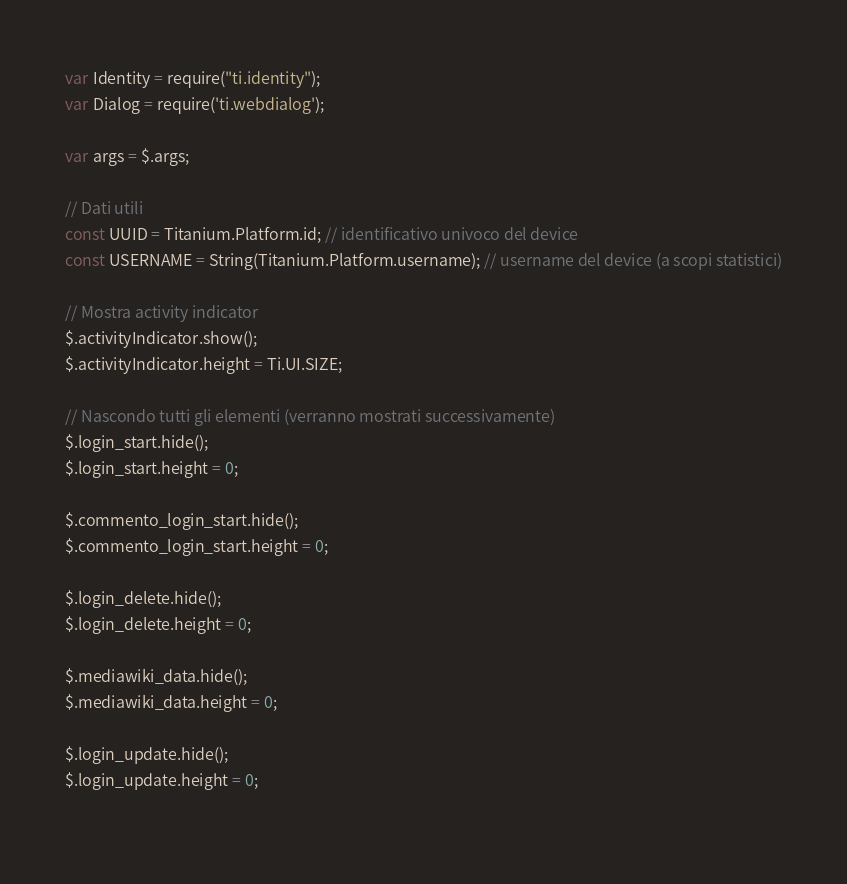Convert code to text. <code><loc_0><loc_0><loc_500><loc_500><_JavaScript_>var Identity = require("ti.identity");
var Dialog = require('ti.webdialog');

var args = $.args;

// Dati utili
const UUID = Titanium.Platform.id; // identificativo univoco del device
const USERNAME = String(Titanium.Platform.username); // username del device (a scopi statistici)

// Mostra activity indicator
$.activityIndicator.show();
$.activityIndicator.height = Ti.UI.SIZE;

// Nascondo tutti gli elementi (verranno mostrati successivamente)
$.login_start.hide();
$.login_start.height = 0;

$.commento_login_start.hide();
$.commento_login_start.height = 0;

$.login_delete.hide();
$.login_delete.height = 0;

$.mediawiki_data.hide();
$.mediawiki_data.height = 0;

$.login_update.hide();
$.login_update.height = 0;
    </code> 